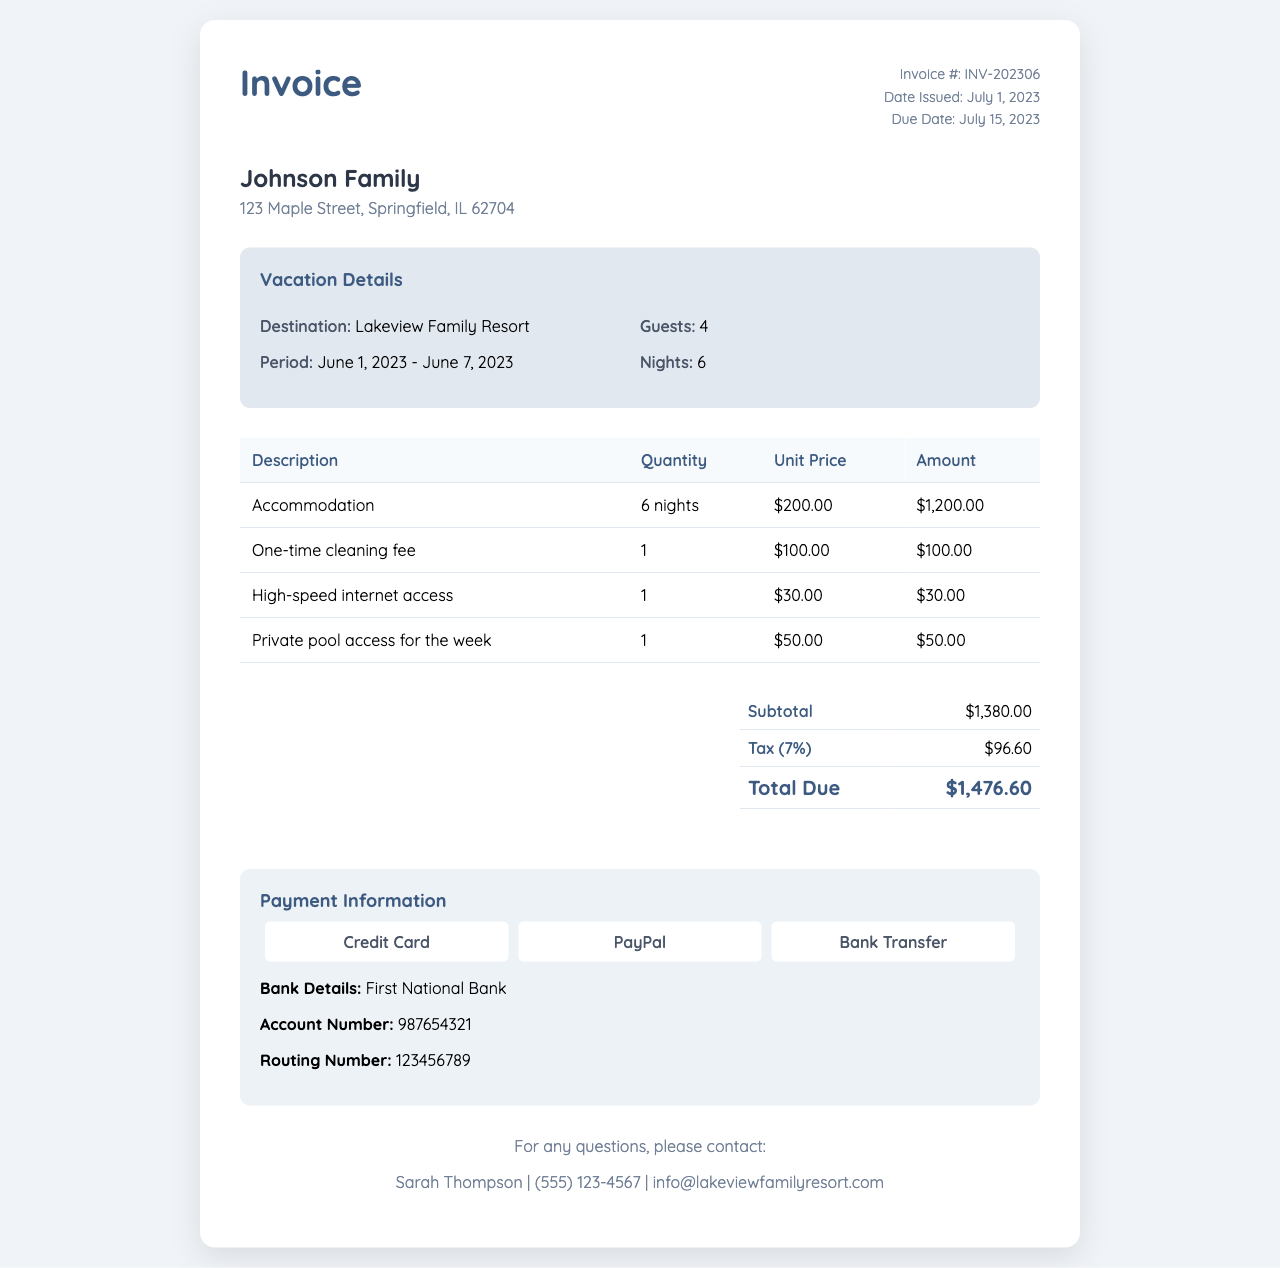What is the invoice number? The invoice number is mentioned at the top of the document.
Answer: INV-202306 What is the due date? The due date is provided in the invoice details section.
Answer: July 15, 2023 What is the total due amount? The total due amount is calculated in the total section of the invoice.
Answer: $1,476.60 How many nights was the accommodation for? The number of nights is specified in the vacation details section.
Answer: 6 What is the unit price for high-speed internet access? The unit price for high-speed internet access can be found in the itemized services table.
Answer: $30.00 What was the cleaning fee? The cleaning fee is listed in the table within the invoice.
Answer: $100.00 What is the tax rate applied? The tax rate can be inferred from the tax calculation in the total section.
Answer: 7% What services are included in the additional charges? Additional charges are detailed in the itemized table section of the invoice.
Answer: One-time cleaning fee, High-speed internet access, Private pool access Which payment methods are available? The payment methods are listed in the payment information section.
Answer: Credit Card, PayPal, Bank Transfer 